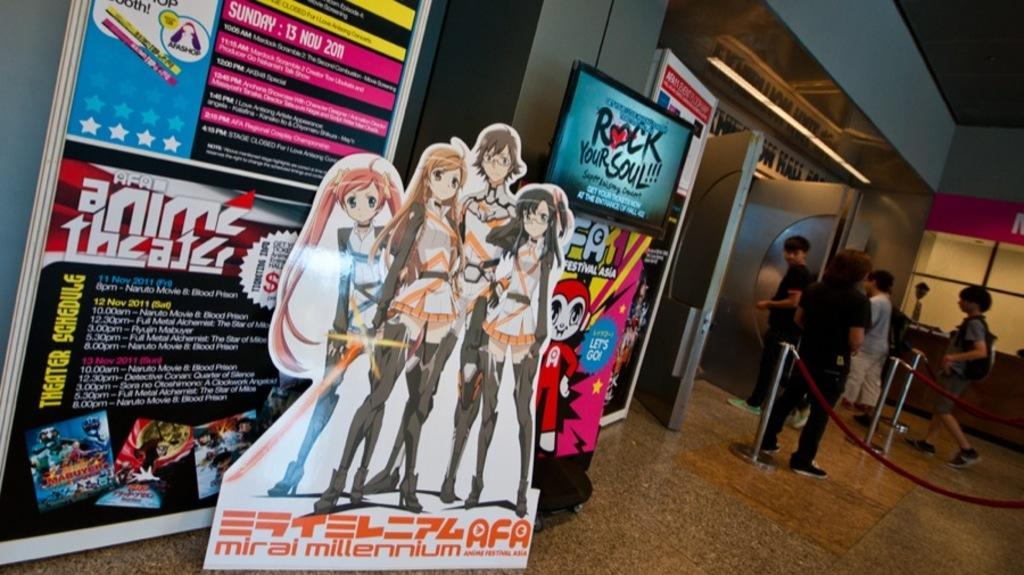Provide a one-sentence caption for the provided image. A display in a theater that says, "Anime Theater". 